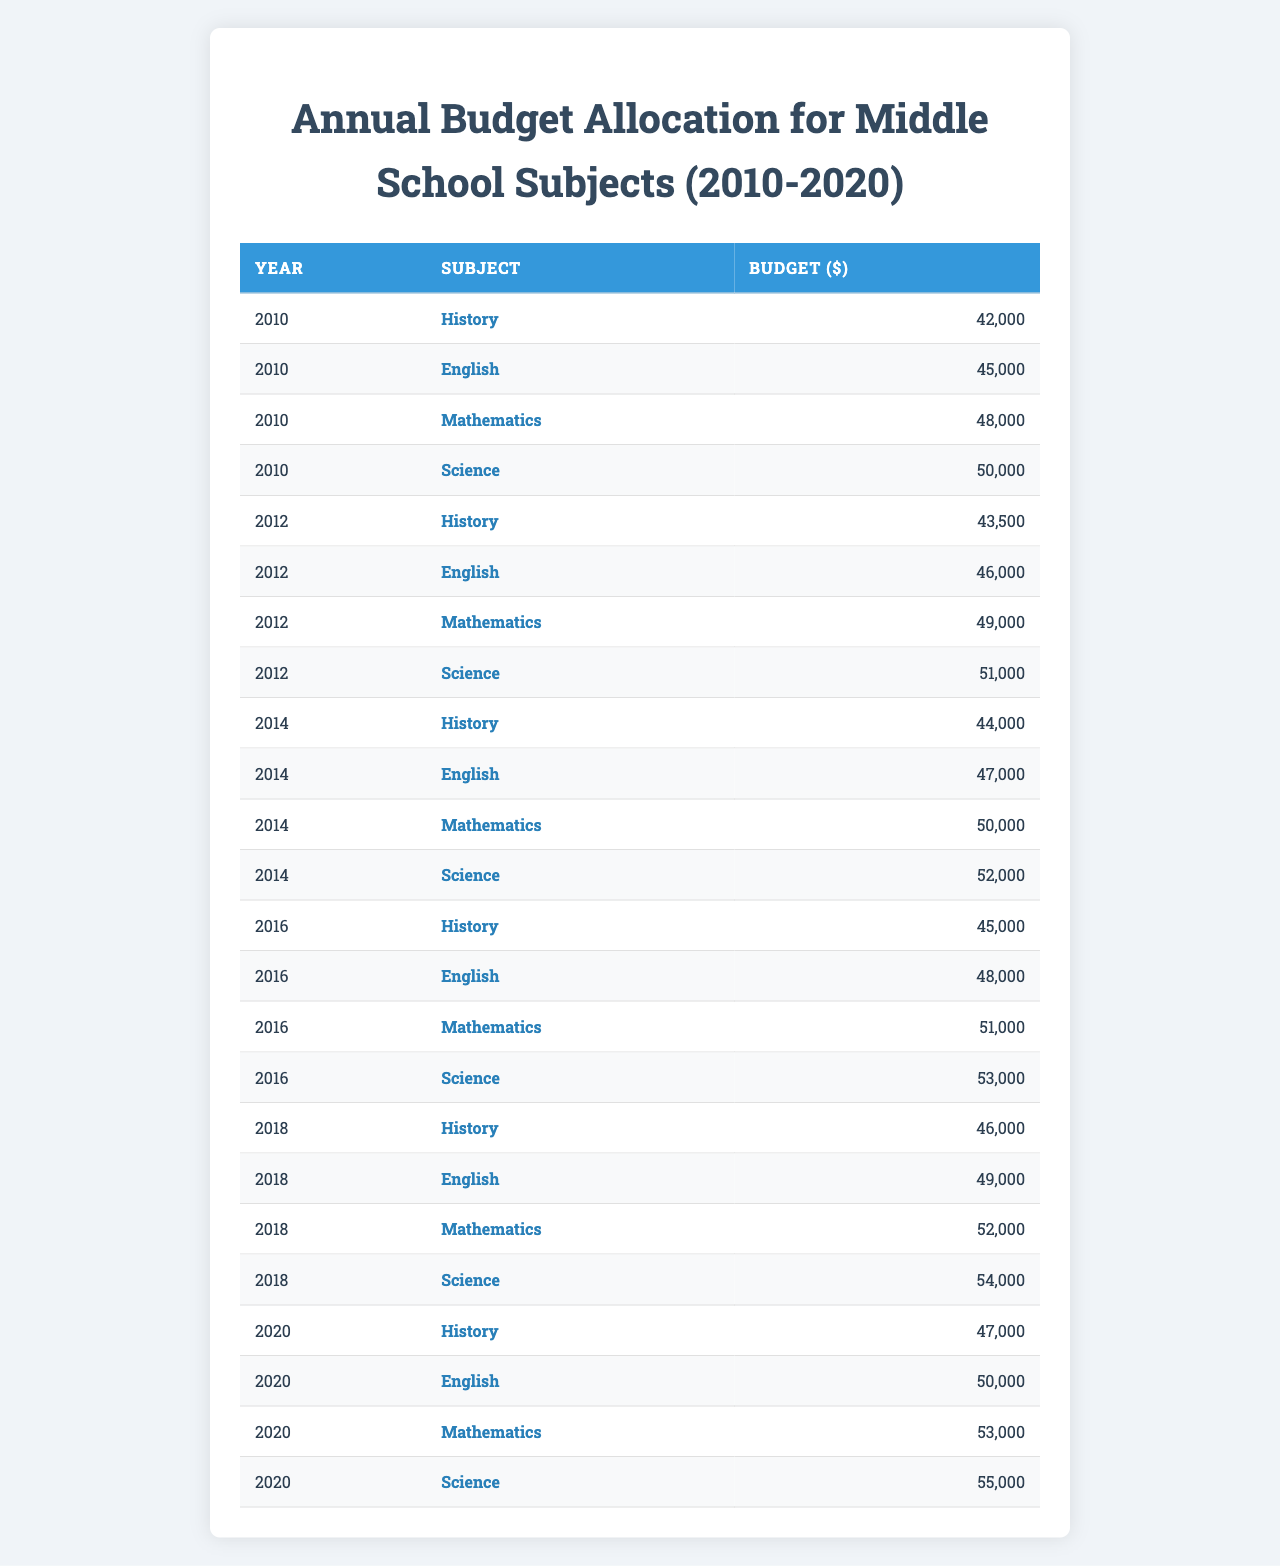What was the budget for Science in 2010? The table shows that in the year 2010, the budget allocated for Science was $50,000.
Answer: $50,000 What is the budget for History in 2020? According to the table, the budget for History in 2020 was $47,000.
Answer: $47,000 Which subject had the highest budget in 2018? By comparing the budgets in 2018: History ($46,000), English ($49,000), Mathematics ($52,000), and Science ($54,000), Science had the highest budget at $54,000.
Answer: Science What was the change in the budget for English from 2010 to 2020? The budget for English in 2010 was $45,000 and in 2020 it was $50,000. The change is $50,000 - $45,000 = $5,000.
Answer: $5,000 Calculate the average budget for Mathematics over the years. The budgets for Mathematics from 2010 to 2020 are: $48,000 (2010), $49,000 (2012), $50,000 (2014), $51,000 (2016), $52,000 (2018), and $53,000 (2020). The total is $48,000 + $49,000 + $50,000 + $51,000 + $52,000 + $53,000 = $303,000. There are 6 years, so the average is $303,000 / 6 = $50,500.
Answer: $50,500 Did the budget for History decrease from 2018 to 2020? The budget for History was $46,000 in 2018 and $47,000 in 2020, indicating an increase, not a decrease.
Answer: No Which subject showed the largest increase in budget from 2010 to 2020? Comparing the budgets from 2010 to 2020: History increased from $42,000 to $47,000 (+$5,000), English from $45,000 to $50,000 (+$5,000), Mathematics from $48,000 to $53,000 (+$5,000), and Science from $50,000 to $55,000 (+$5,000). All subjects increased by $5,000, so there is no single largest increase.
Answer: No single largest increase What was the total budget allocated for all subjects in 2016? The budgets for all subjects in 2016 are: History ($45,000), English ($48,000), Mathematics ($51,000), Science ($53,000). Summing these gives $45,000 + $48,000 + $51,000 + $53,000 = $197,000.
Answer: $197,000 What is the trend in budget allocation for Science from 2010 to 2020? The budget for Science increased yearly: $50,000 (2010), $51,000 (2012), $52,000 (2014), $53,000 (2016), $54,000 (2018), and $55,000 (2020). This shows a consistent upward trend in budget allocation over the years.
Answer: Consistent increase Was the budget for Mathematics higher than that for English in 2014? In 2014, Mathematics had a budget of $50,000 while English had a budget of $47,000. Since $50,000 is greater than $47,000, Mathematics was higher than English that year.
Answer: Yes What happens to the budget for History between 2010 and 2018? The budget for History increased from $42,000 in 2010 to $46,000 in 2018, showing a positive change of $4,000 over the eight years.
Answer: Increased by $4,000 